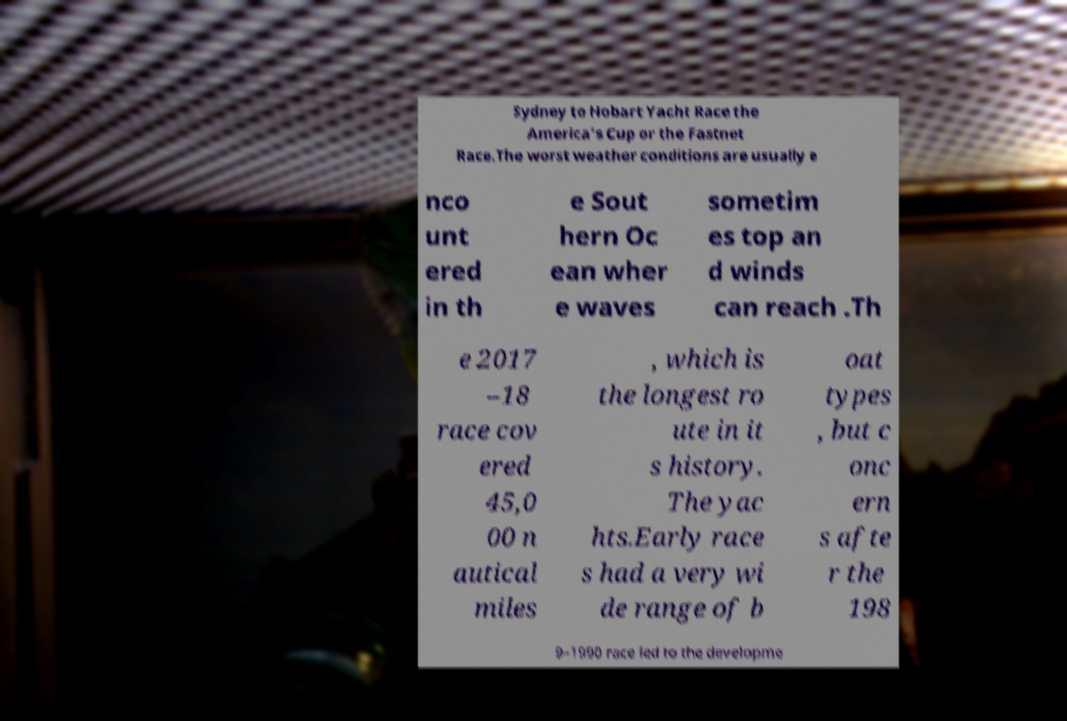I need the written content from this picture converted into text. Can you do that? Sydney to Hobart Yacht Race the America's Cup or the Fastnet Race.The worst weather conditions are usually e nco unt ered in th e Sout hern Oc ean wher e waves sometim es top an d winds can reach .Th e 2017 –18 race cov ered 45,0 00 n autical miles , which is the longest ro ute in it s history. The yac hts.Early race s had a very wi de range of b oat types , but c onc ern s afte r the 198 9–1990 race led to the developme 